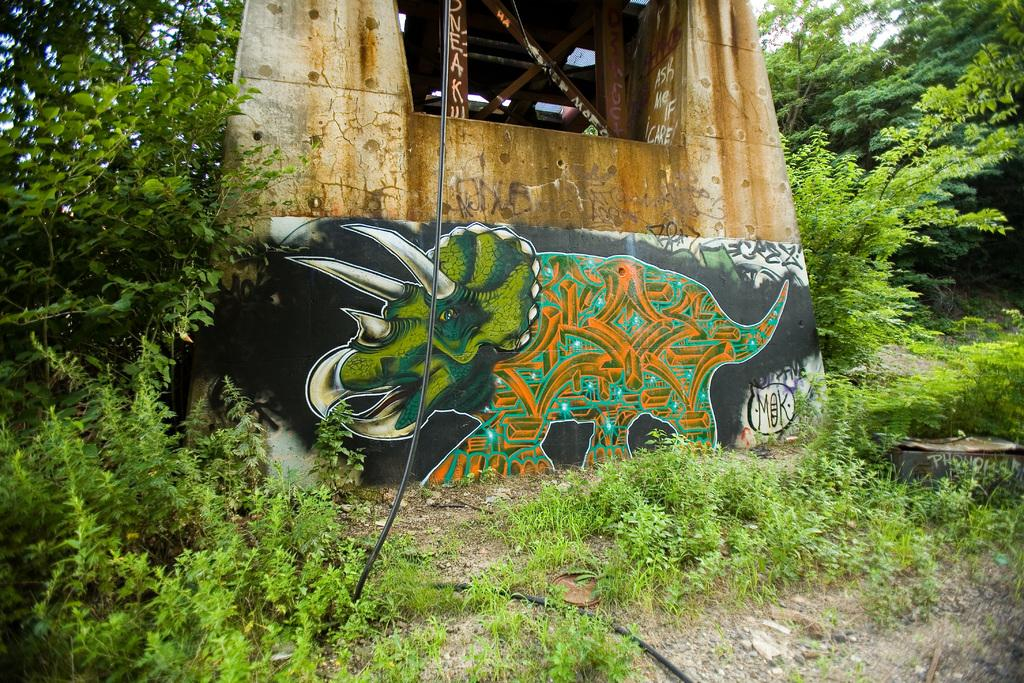What type of living organisms can be seen in the image? Plants can be seen in the image. What is visible in the background of the image? There is a wall in the background of the image. What is on the wall? There is a painting on the wall. What else can be seen in the image? There is a wire visible in the image. How many beads are on the girl's necklace in the image? There is no girl or necklace present in the image. 